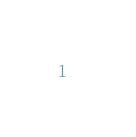Convert code to text. <code><loc_0><loc_0><loc_500><loc_500><_SQL_>

</code> 